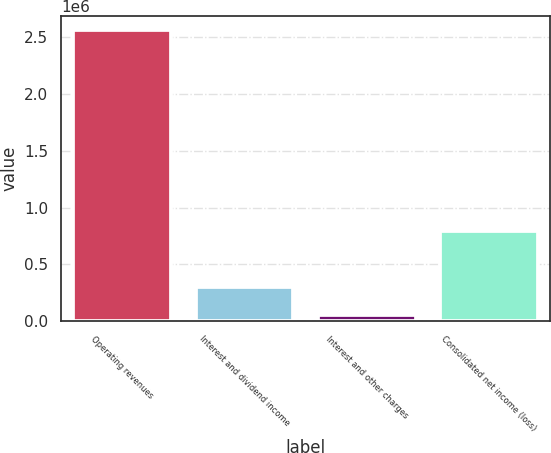<chart> <loc_0><loc_0><loc_500><loc_500><bar_chart><fcel>Operating revenues<fcel>Interest and dividend income<fcel>Interest and other charges<fcel>Consolidated net income (loss)<nl><fcel>2.55838e+06<fcel>304371<fcel>53926<fcel>797280<nl></chart> 